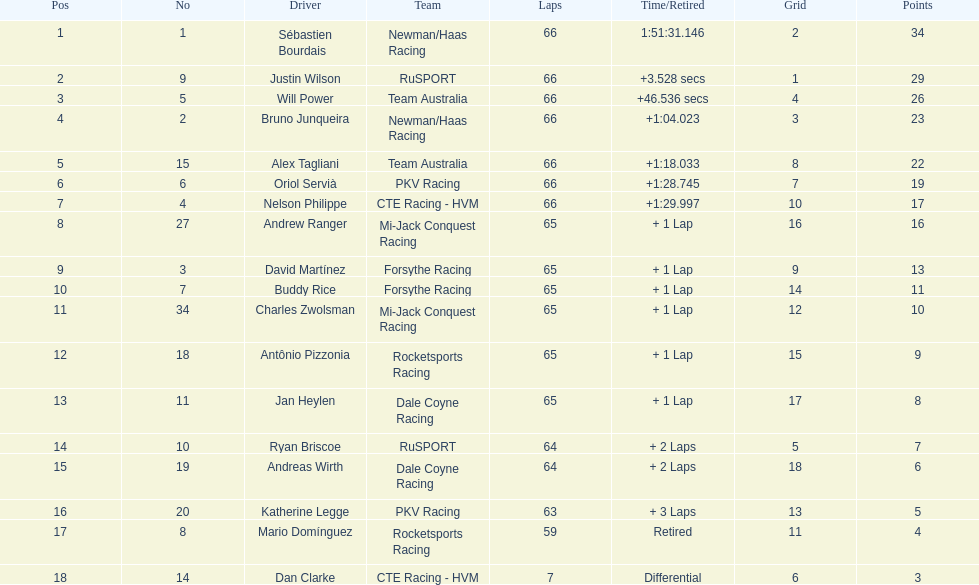In the 2006 gran premio telmex, what was the number of drivers who finished fewer than 60 laps? 2. 